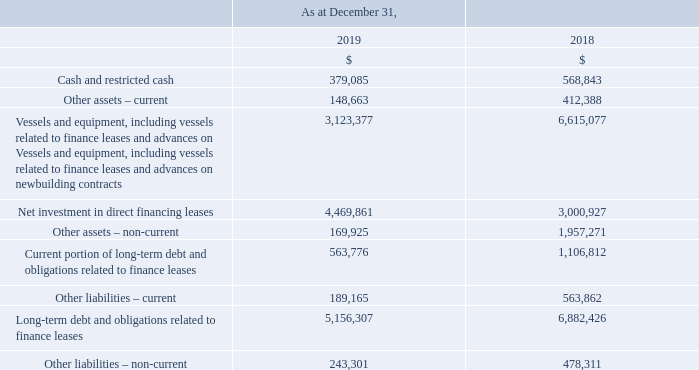A condensed summary of the Company’s financial information for equity-accounted investments (20% to 52%-owned) shown on a 100% basis (excluding the impact from purchase price adjustments arising from the acquisition of Joint Ventures) are as follows:
The results included for TIL are until its consolidation on November 27, 2017. The results included for Altera are from the date of deconsolidation on September 25, 2017 to the sale of Teekay's remaining interests on May 8, 2019.
For the year ended December 31, 2019, the Company recorded equity loss of $14.5 million (2018 – income of $61.1 million, and 2017 – loss of $37.3 million).
The equity loss in 2019 was primarily comprised of the write-down and loss on sale of Teekay's investment in Altera and the Company’s share of net loss from the Bahrain LNG Joint Venture; offset by equity income in the Yamal LNG Joint Venture, the RasGas III Joint Venture, the MALT Joint Venture, the Pan Union Joint Venture and the Angola Joint Venture.
For the year ended December 31, 2019, equity loss included $12.9 million related to the Company’s share of unrealized losses on interest rate swaps in the equity-accounted investments (2018 – gains of $17.6 million and 2017 – gains of $7.7 million).
How much was the equity loss for the year ended December 31, 2019? For the year ended december 31, 2019, the company recorded equity loss of $14.5 million. What is the increase/ (decrease) in Cash and restricted cash from December 31, 2019 to December 31, 2018?
Answer scale should be: million. 379,085-568,843
Answer: -189758. What is the increase/ (decrease) in Other assets – current from December 31, 2019 to December 31, 2018?
Answer scale should be: million. 148,663-412,388
Answer: -263725. In which year was cash and restricted cash less than 400,000 million? Locate and analyze cash and restricted cash in row 4
answer: 2019. What was the other assets - current in 2019 and 2018?
Answer scale should be: million. 148,663, 412,388. What did the equity loss comprise of in 2019? Comprised of the write-down and loss on sale of teekay's investment in altera and the company’s share of net loss from the bahrain lng joint venture; offset by equity income in the yamal lng joint venture, the rasgas iii joint venture, the malt joint venture, the pan union joint venture and the angola joint venture. 